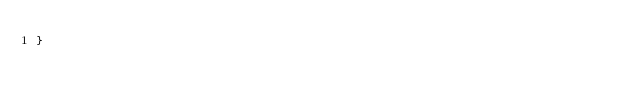<code> <loc_0><loc_0><loc_500><loc_500><_Go_>}
</code> 